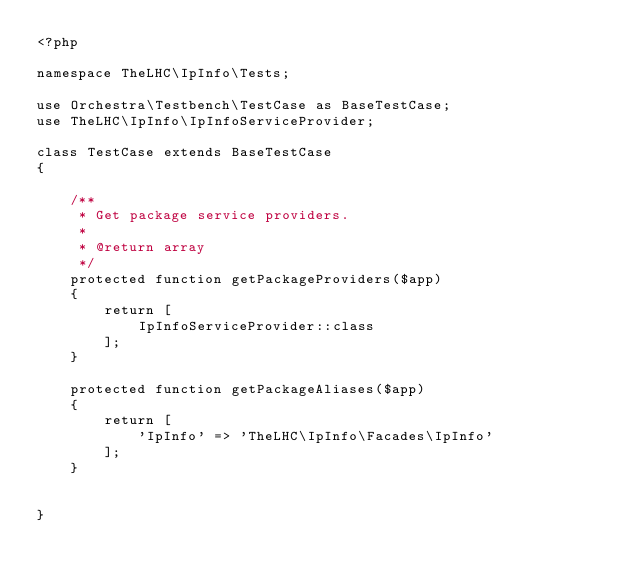Convert code to text. <code><loc_0><loc_0><loc_500><loc_500><_PHP_><?php

namespace TheLHC\IpInfo\Tests;

use Orchestra\Testbench\TestCase as BaseTestCase;
use TheLHC\IpInfo\IpInfoServiceProvider;

class TestCase extends BaseTestCase
{

    /**
     * Get package service providers.
     *
     * @return array
     */
    protected function getPackageProviders($app)
    {
        return [
            IpInfoServiceProvider::class
        ];
    }

    protected function getPackageAliases($app)
    {
        return [
            'IpInfo' => 'TheLHC\IpInfo\Facades\IpInfo'
        ];
    }


}
</code> 